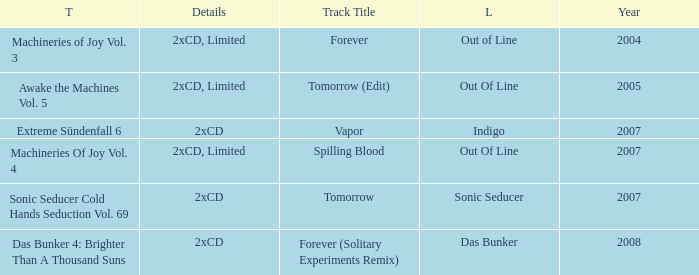Which details has the out of line label and the year of 2005? 2xCD, Limited. 